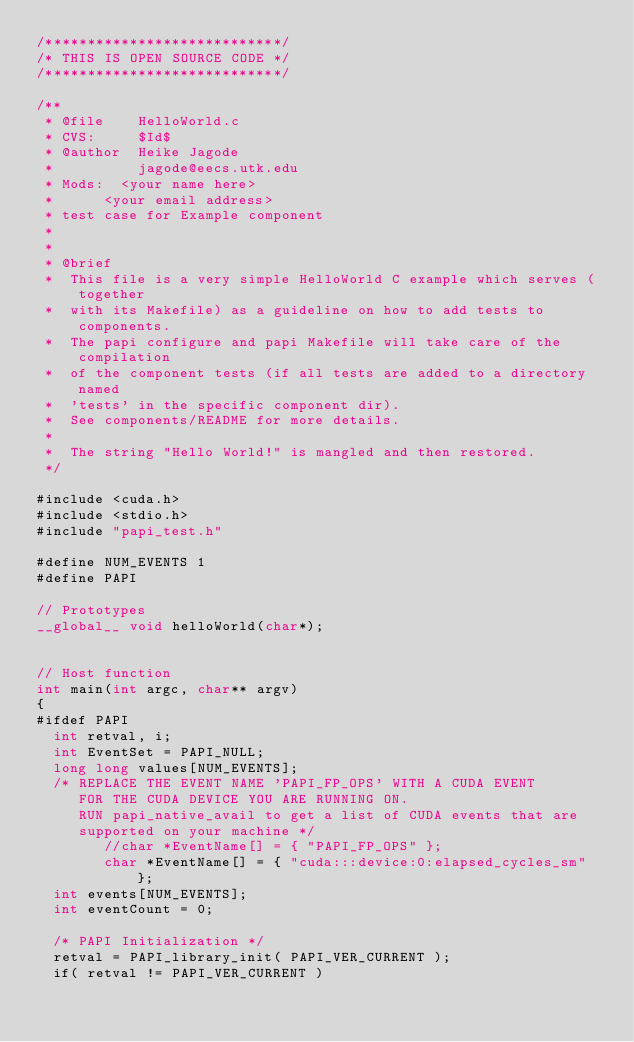Convert code to text. <code><loc_0><loc_0><loc_500><loc_500><_Cuda_>/****************************/
/* THIS IS OPEN SOURCE CODE */
/****************************/

/** 
 * @file    HelloWorld.c
 * CVS:     $Id$
 * @author  Heike Jagode
 *          jagode@eecs.utk.edu
 * Mods:	<your name here>
 *			<your email address>
 * test case for Example component 
 * 
 *
 * @brief
 *  This file is a very simple HelloWorld C example which serves (together
 *	with its Makefile) as a guideline on how to add tests to components.
 *  The papi configure and papi Makefile will take care of the compilation
 *	of the component tests (if all tests are added to a directory named
 *	'tests' in the specific component dir).
 *	See components/README for more details.
 *
 *	The string "Hello World!" is mangled and then restored.
 */

#include <cuda.h>
#include <stdio.h>
#include "papi_test.h"

#define NUM_EVENTS 1
#define PAPI

// Prototypes
__global__ void helloWorld(char*);


// Host function
int main(int argc, char** argv)
{
#ifdef PAPI
	int retval, i;
	int EventSet = PAPI_NULL;
	long long values[NUM_EVENTS];
	/* REPLACE THE EVENT NAME 'PAPI_FP_OPS' WITH A CUDA EVENT 
	   FOR THE CUDA DEVICE YOU ARE RUNNING ON.
	   RUN papi_native_avail to get a list of CUDA events that are 
	   supported on your machine */
        //char *EventName[] = { "PAPI_FP_OPS" };
        char *EventName[] = { "cuda:::device:0:elapsed_cycles_sm" };
	int events[NUM_EVENTS];
	int eventCount = 0;
	
	/* PAPI Initialization */
	retval = PAPI_library_init( PAPI_VER_CURRENT );
	if( retval != PAPI_VER_CURRENT )</code> 